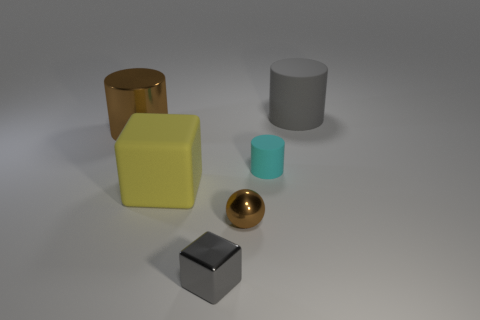What shape is the big metallic thing that is the same color as the ball?
Offer a terse response. Cylinder. The metal thing on the right side of the gray thing in front of the big thing behind the large metallic cylinder is what color?
Provide a short and direct response. Brown. There is a cube that is in front of the yellow object that is in front of the big shiny cylinder; what color is it?
Offer a very short reply. Gray. Are there more large brown cylinders behind the big yellow thing than tiny gray metal cubes behind the tiny shiny cube?
Your response must be concise. Yes. Does the gray thing in front of the big metal object have the same material as the tiny object behind the matte block?
Provide a succinct answer. No. There is a brown sphere; are there any big brown metallic things left of it?
Your answer should be compact. Yes. What number of red objects are either tiny blocks or small cylinders?
Your answer should be very brief. 0. Do the gray cube and the large cylinder to the left of the tiny gray shiny object have the same material?
Ensure brevity in your answer.  Yes. There is a cyan object that is the same shape as the large brown shiny object; what size is it?
Your answer should be very brief. Small. What is the material of the gray cube?
Provide a short and direct response. Metal. 